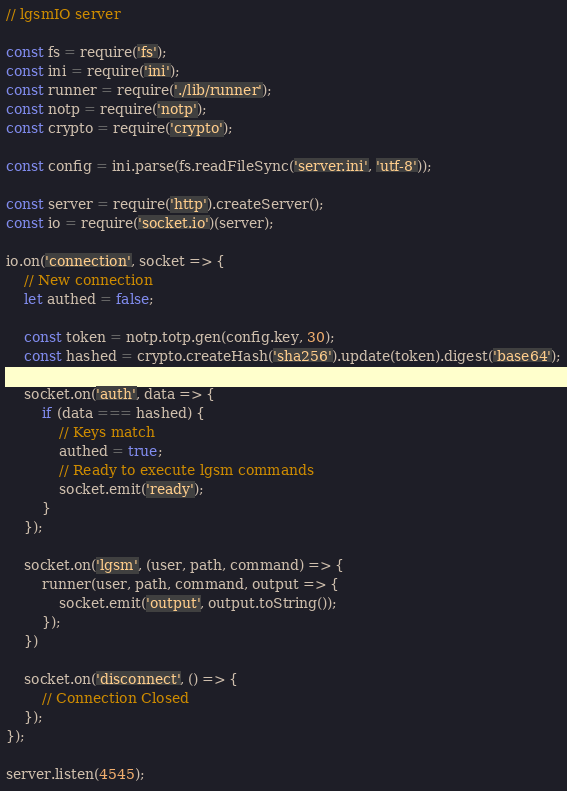<code> <loc_0><loc_0><loc_500><loc_500><_JavaScript_>// lgsmIO server

const fs = require('fs');
const ini = require('ini');
const runner = require('./lib/runner');
const notp = require('notp');
const crypto = require('crypto');

const config = ini.parse(fs.readFileSync('server.ini', 'utf-8'));

const server = require('http').createServer();
const io = require('socket.io')(server);

io.on('connection', socket => {
    // New connection
    let authed = false;

    const token = notp.totp.gen(config.key, 30); 
    const hashed = crypto.createHash('sha256').update(token).digest('base64');

    socket.on('auth', data => {
        if (data === hashed) {
            // Keys match
            authed = true;
            // Ready to execute lgsm commands
            socket.emit('ready');
        }
    });

    socket.on('lgsm', (user, path, command) => {
        runner(user, path, command, output => {
            socket.emit('output', output.toString());
        });
    })

    socket.on('disconnect', () => {
        // Connection Closed
    });
});

server.listen(4545);

</code> 